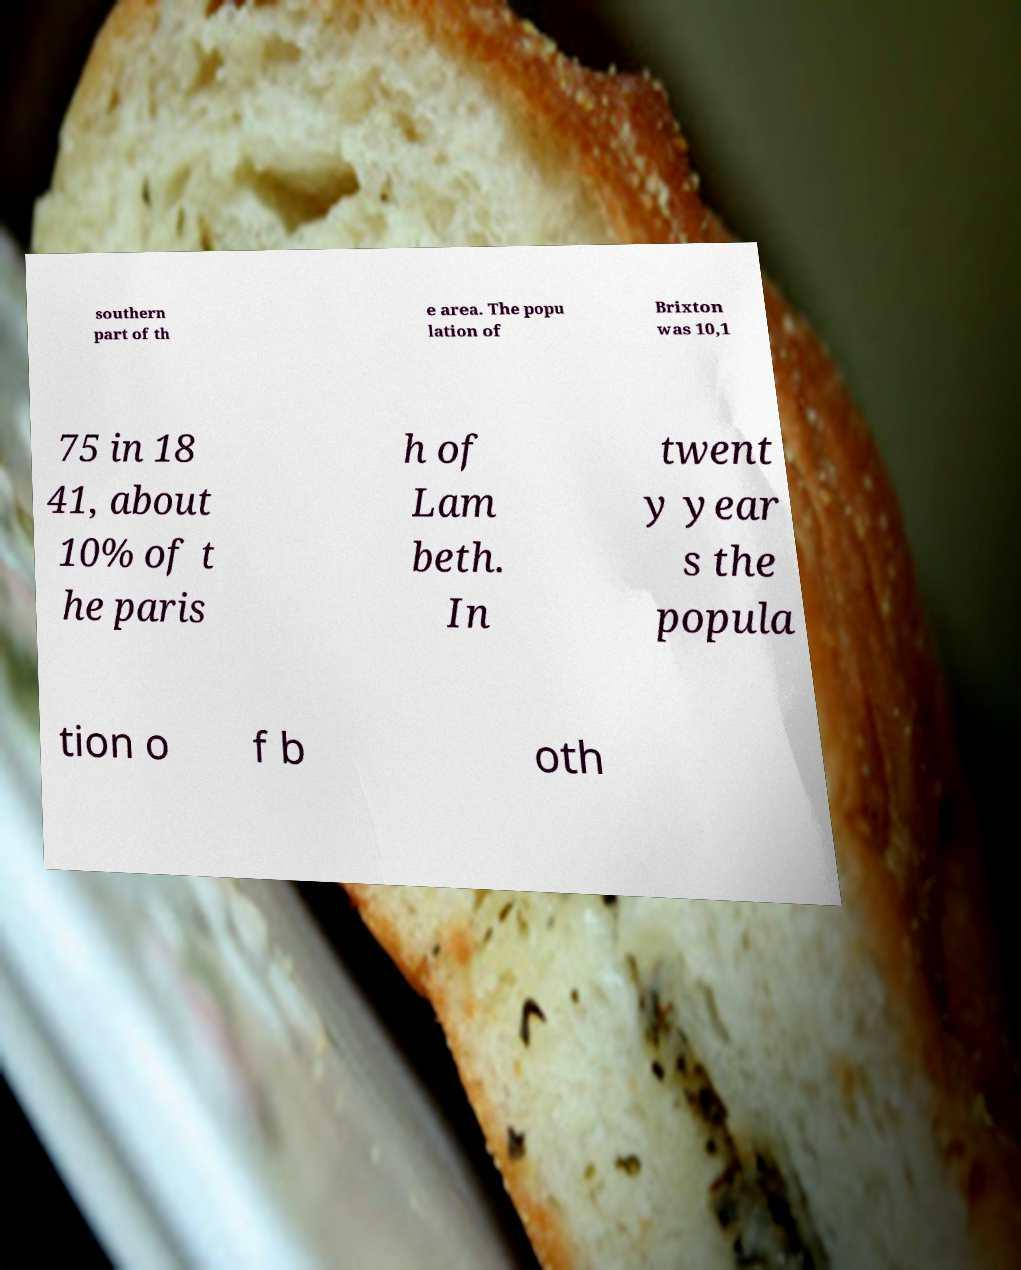Can you accurately transcribe the text from the provided image for me? southern part of th e area. The popu lation of Brixton was 10,1 75 in 18 41, about 10% of t he paris h of Lam beth. In twent y year s the popula tion o f b oth 